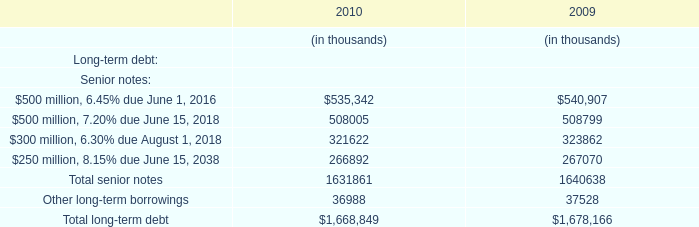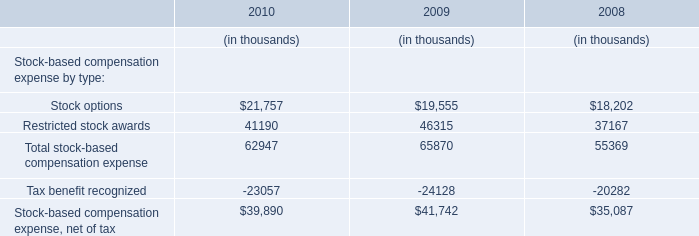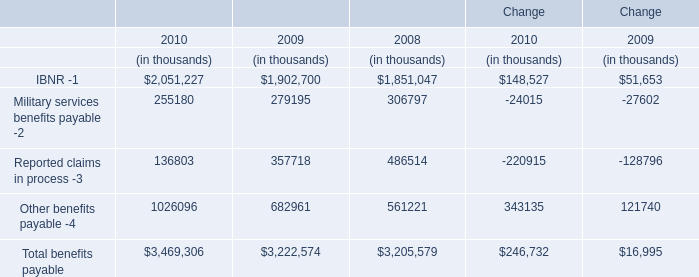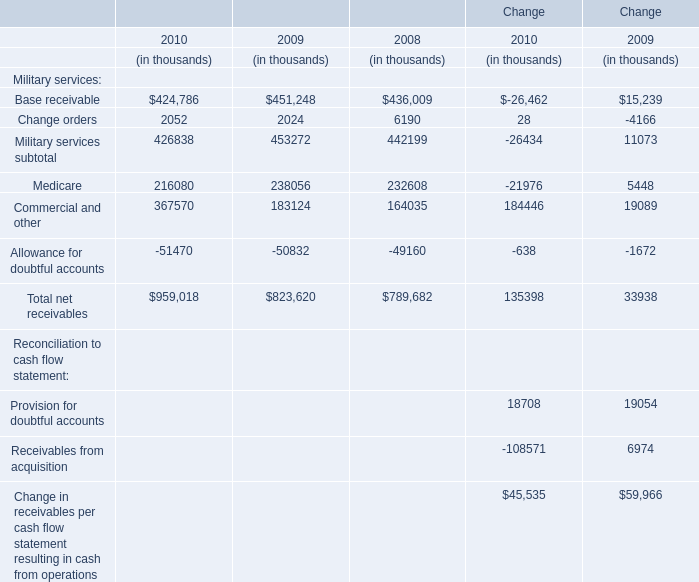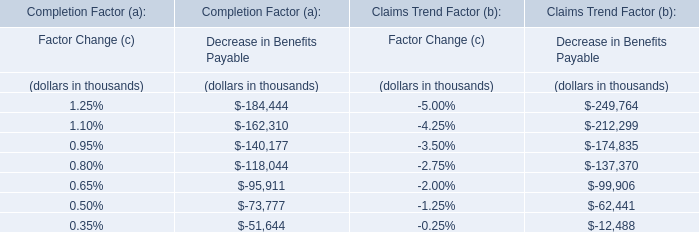What's the 10 % of total benefits payable in 2010? (in thousand) 
Computations: (0.1 * 3469306)
Answer: 346930.6. 